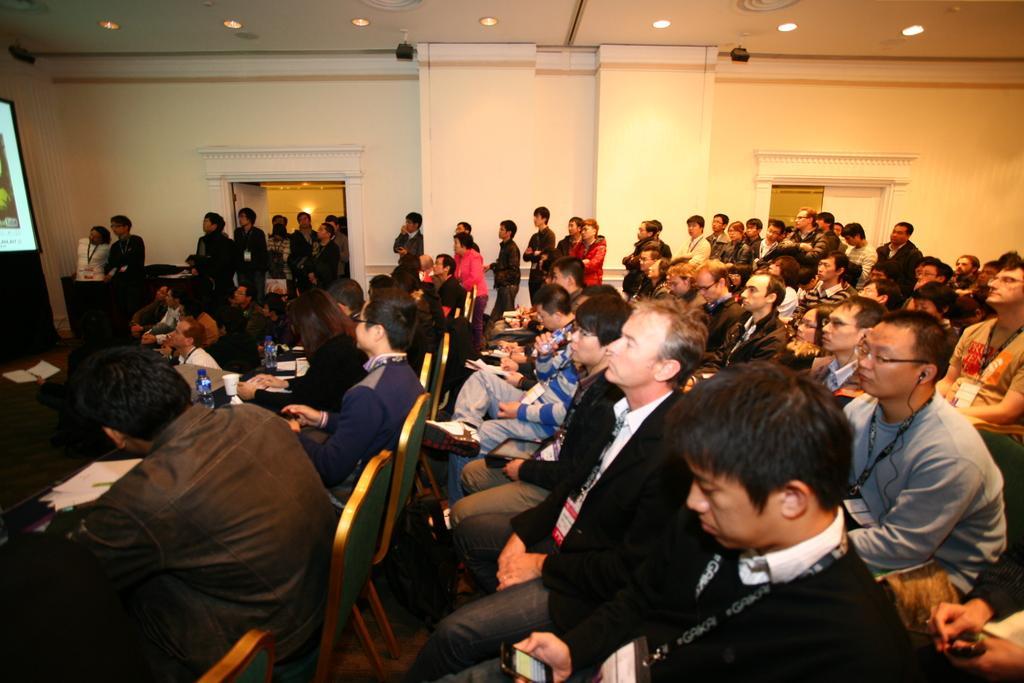Could you give a brief overview of what you see in this image? This image is taken indoors. In the background there is a wall and there are two doors. There are two pillars. At the top of the image there is a ceiling with a few lights. There are two CC cams. On the left side of the image there is a screen. In the middle of the image many people are sitting on the chairs and they are holding devices, books and pens in their hands. There are a few tables with a few things on them. A few people are standing on the floor. 